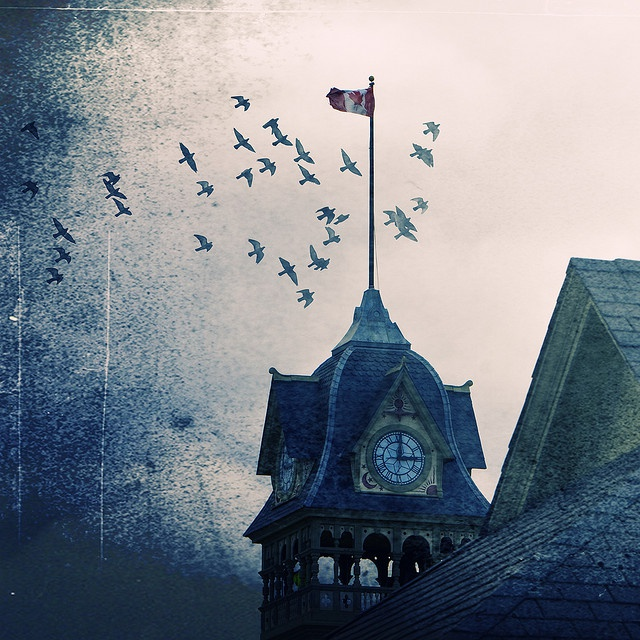Describe the objects in this image and their specific colors. I can see bird in black, lightgray, darkgray, blue, and navy tones, clock in black, gray, navy, and blue tones, clock in black, navy, blue, and gray tones, bird in black, blue, navy, and gray tones, and bird in black, navy, blue, and gray tones in this image. 